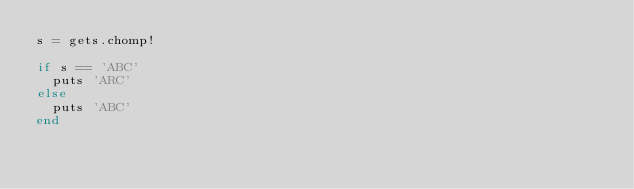Convert code to text. <code><loc_0><loc_0><loc_500><loc_500><_Ruby_>s = gets.chomp!

if s == 'ABC'
  puts 'ARC'
else
  puts 'ABC'
end
</code> 